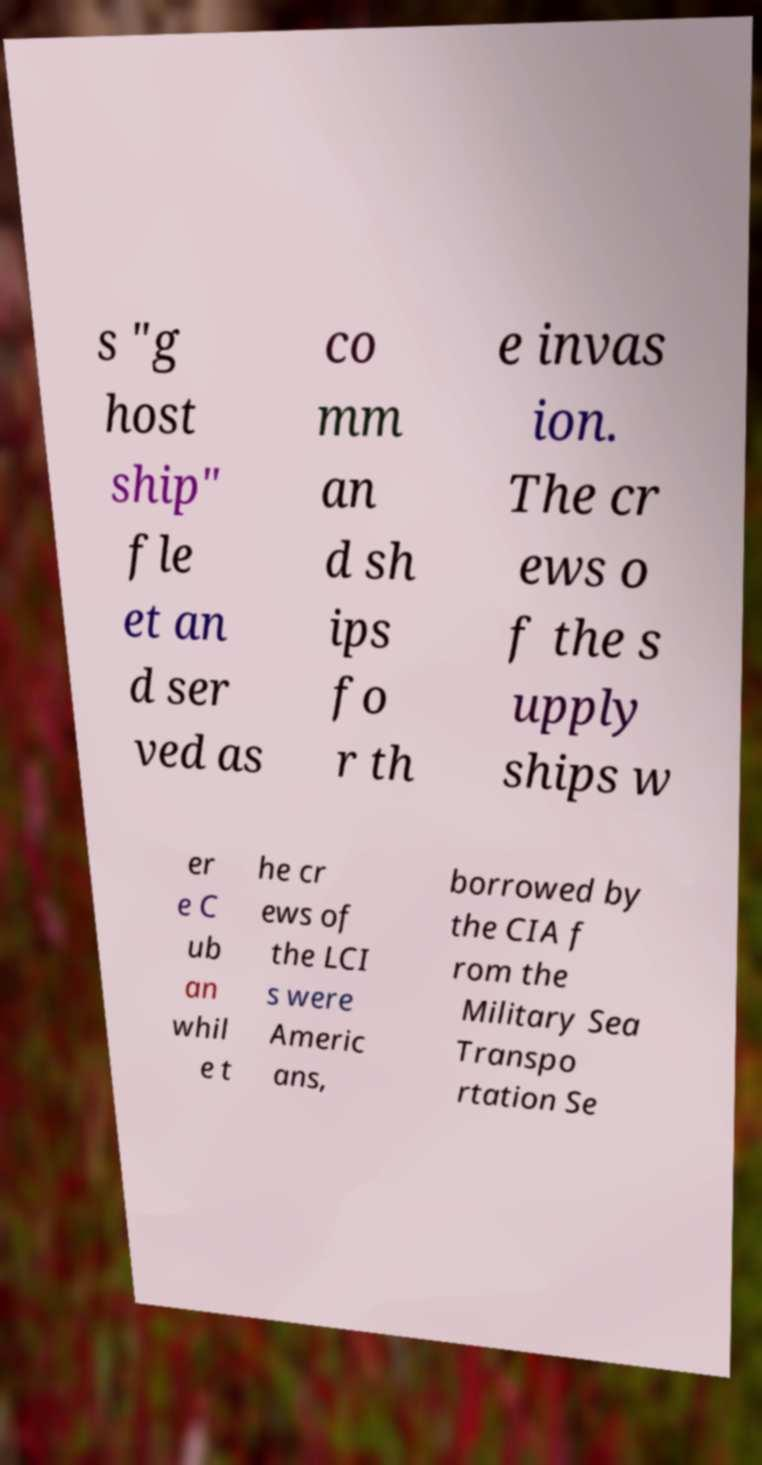Can you accurately transcribe the text from the provided image for me? s "g host ship" fle et an d ser ved as co mm an d sh ips fo r th e invas ion. The cr ews o f the s upply ships w er e C ub an whil e t he cr ews of the LCI s were Americ ans, borrowed by the CIA f rom the Military Sea Transpo rtation Se 